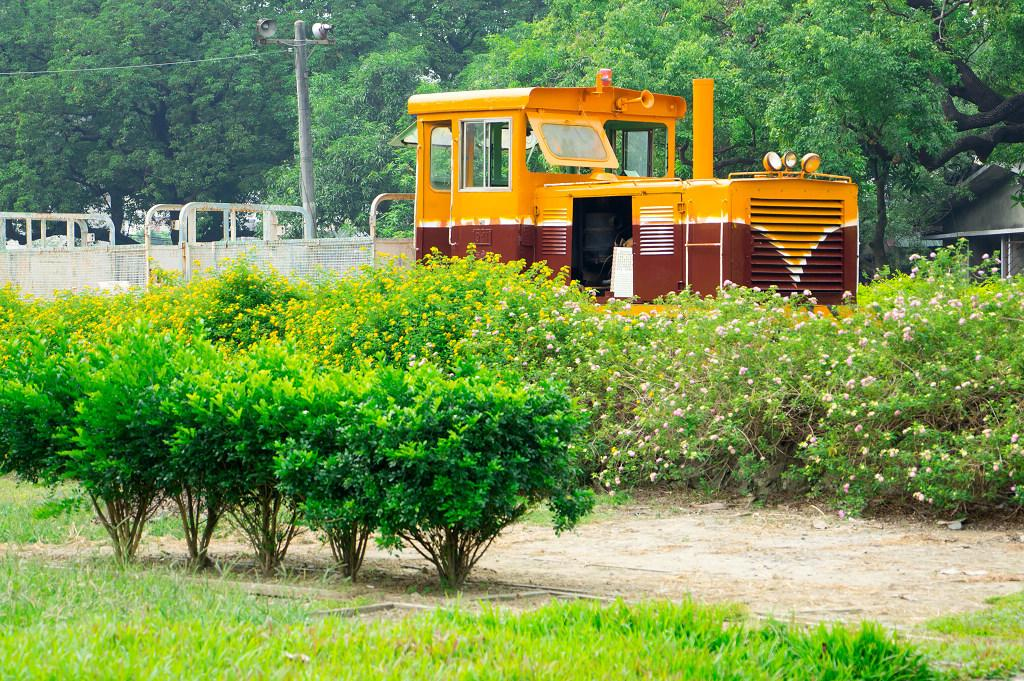What type of vegetation can be seen in the image? There is grass and plants in the image. What is located beside the plants? There is a compartment beside the plants. What can be seen in the background of the image? There are trees, metal rods, a pole, and a house in the background of the image. What type of furniture is visible in the image? There is no furniture present in the image. How many trucks can be seen in the image? There are no trucks present in the image. 